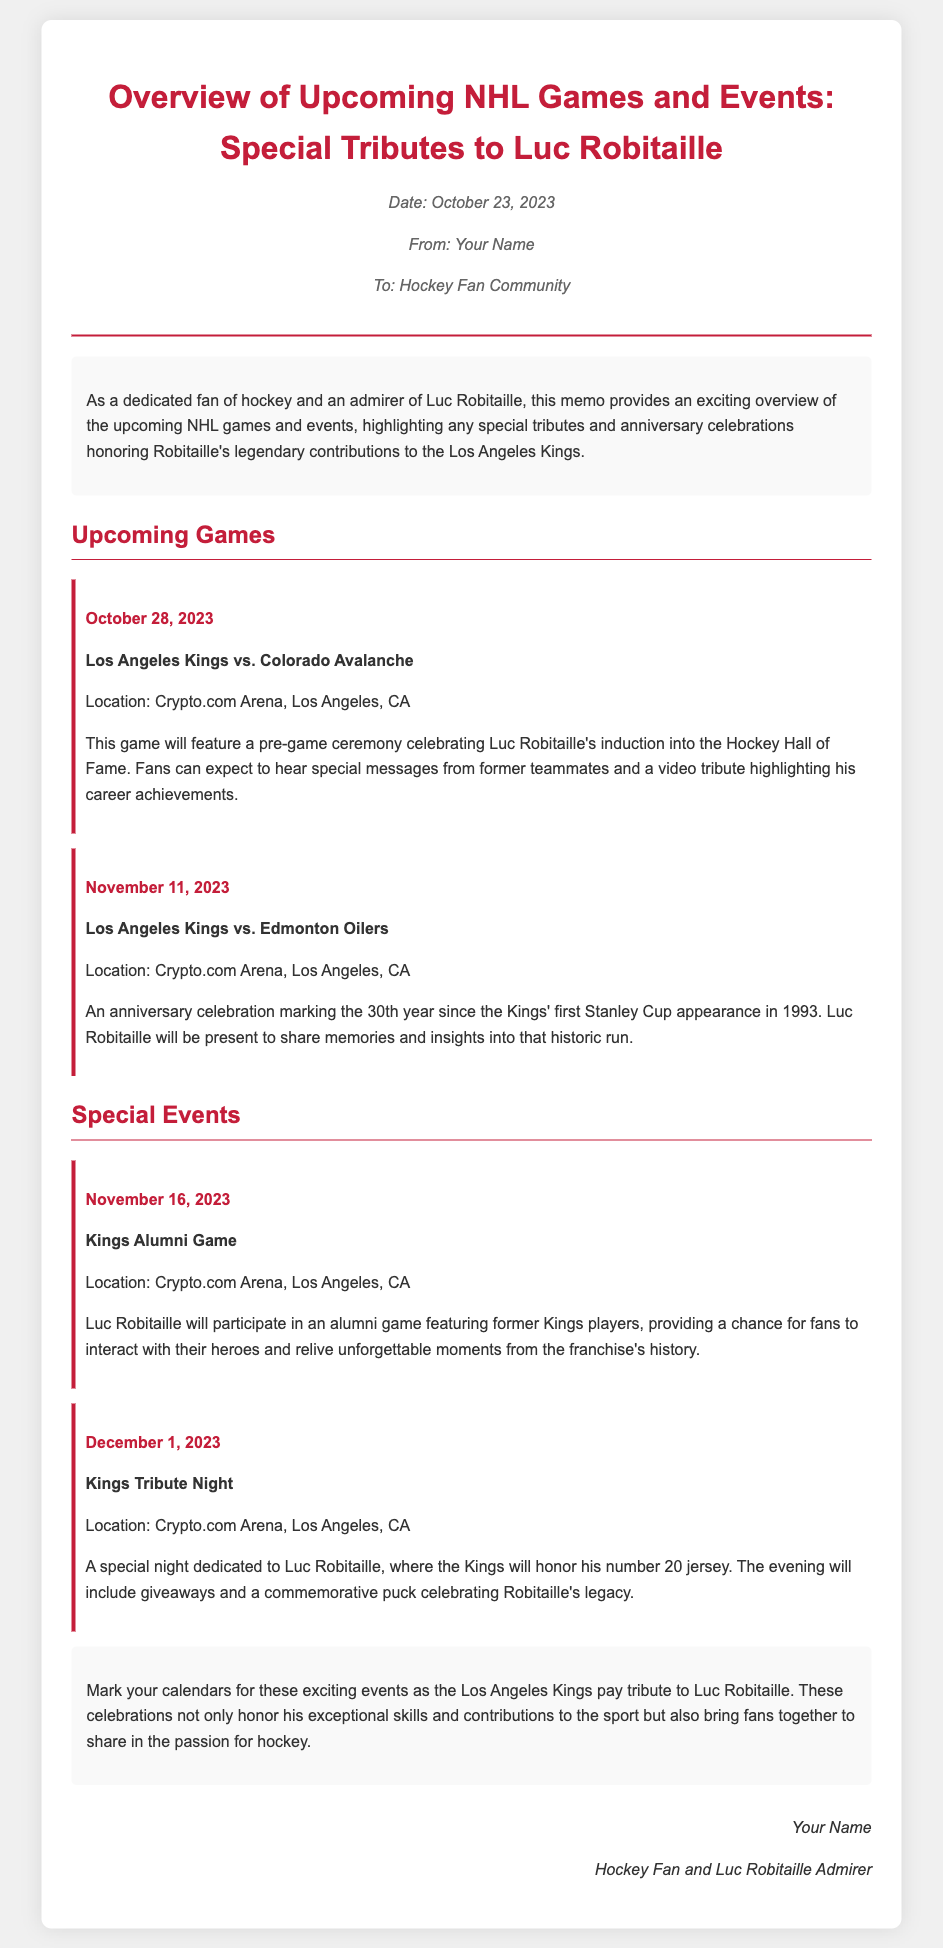What is the date of the first upcoming game? The first upcoming game is on October 28, 2023, as mentioned in the document.
Answer: October 28, 2023 Who are the Los Angeles Kings playing against on November 11, 2023? The document specifies that on November 11, 2023, the Kings will be playing against the Edmonton Oilers.
Answer: Edmonton Oilers What significant event will occur on October 28, 2023? On this date, a pre-game ceremony celebrating Luc Robitaille's induction into the Hockey Hall of Fame will take place.
Answer: A pre-game ceremony How many years since the Kings' first Stanley Cup appearance will be celebrated on November 11, 2023? The document indicates that it will mark the 30th year since the Kings' first Stanley Cup appearance.
Answer: 30th What will Luc Robitaille do during the Kings Alumni Game? The document states that he will participate in the alumni game.
Answer: Participate What special item will be given away on December 1, 2023? A commemorative puck celebrating Robitaille's legacy will be given away during the tribute night.
Answer: Commemorative puck What color is the document's title font? The document specifies that the title font color is a shade represented by the code #c41e3a.
Answer: #c41e3a Who is the memo addressed to? The memo is addressed to the Hockey Fan Community as indicated in the document.
Answer: Hockey Fan Community 